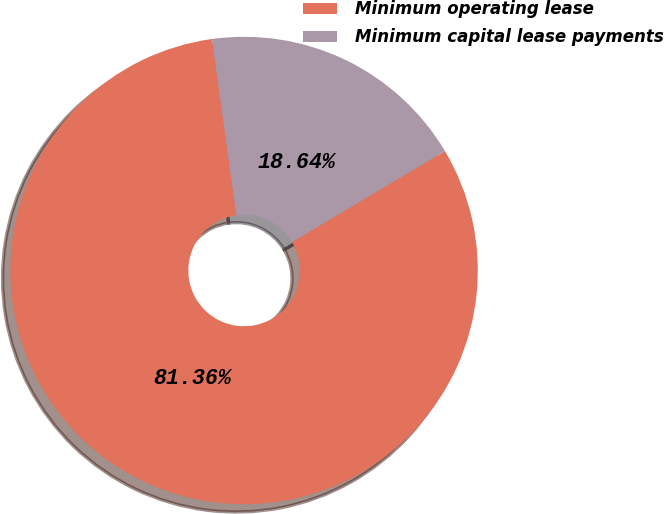Convert chart to OTSL. <chart><loc_0><loc_0><loc_500><loc_500><pie_chart><fcel>Minimum operating lease<fcel>Minimum capital lease payments<nl><fcel>81.36%<fcel>18.64%<nl></chart> 